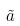Convert formula to latex. <formula><loc_0><loc_0><loc_500><loc_500>\tilde { a }</formula> 